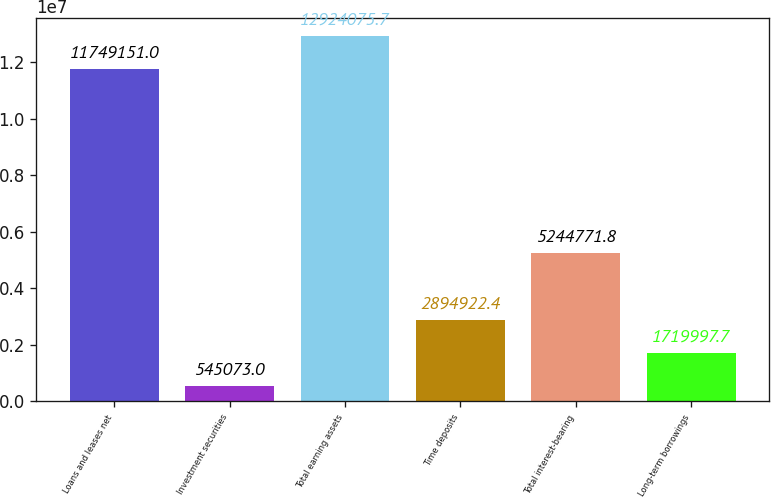Convert chart to OTSL. <chart><loc_0><loc_0><loc_500><loc_500><bar_chart><fcel>Loans and leases net<fcel>Investment securities<fcel>Total earning assets<fcel>Time deposits<fcel>Total interest-bearing<fcel>Long-term borrowings<nl><fcel>1.17492e+07<fcel>545073<fcel>1.29241e+07<fcel>2.89492e+06<fcel>5.24477e+06<fcel>1.72e+06<nl></chart> 